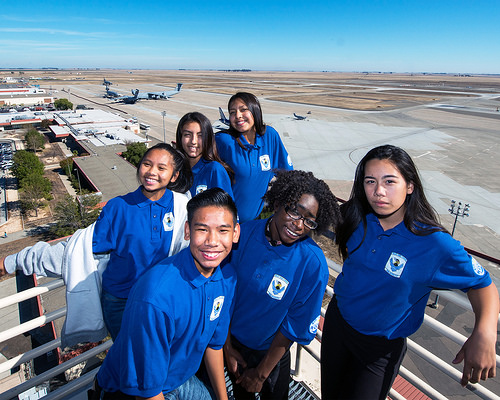<image>
Is the women to the left of the men? Yes. From this viewpoint, the women is positioned to the left side relative to the men. Is the woman in the man? No. The woman is not contained within the man. These objects have a different spatial relationship. 